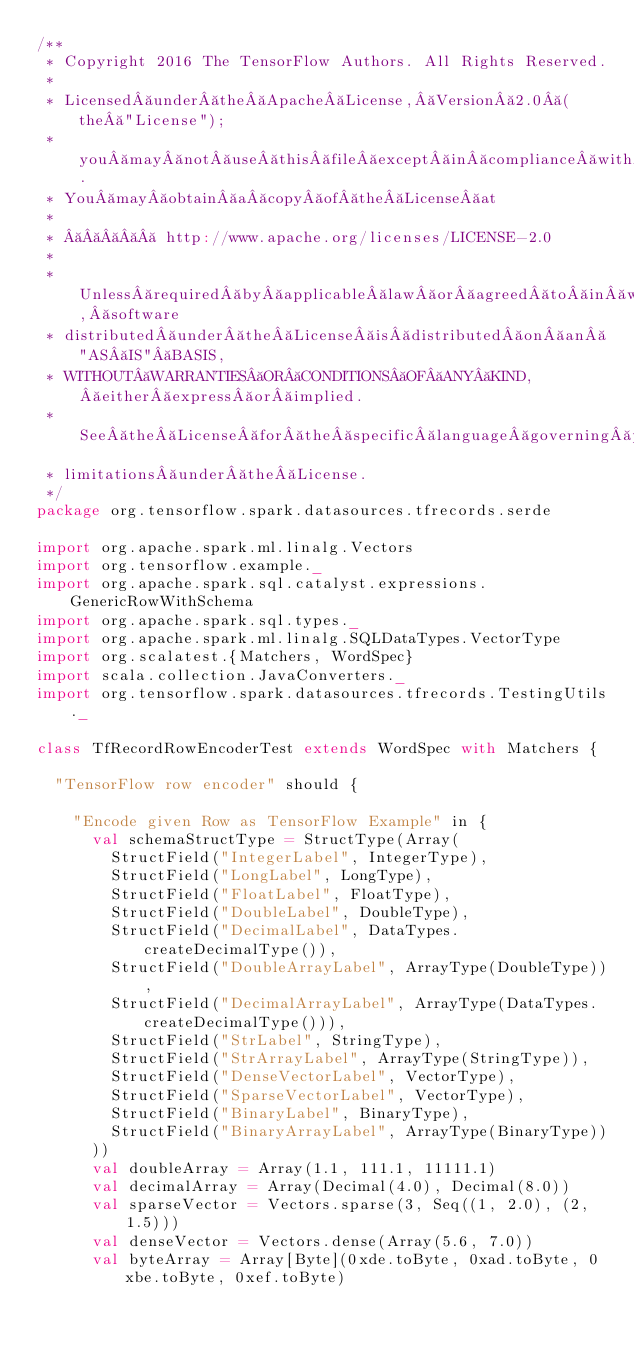<code> <loc_0><loc_0><loc_500><loc_500><_Scala_>/**
 * Copyright 2016 The TensorFlow Authors. All Rights Reserved.
 *
 * Licensed under the Apache License, Version 2.0 (the "License");
 * you may not use this file except in compliance with the License.
 * You may obtain a copy of the License at
 *
 *       http://www.apache.org/licenses/LICENSE-2.0
 *
 * Unless required by applicable law or agreed to in writing, software
 * distributed under the License is distributed on an "AS IS" BASIS,
 * WITHOUT WARRANTIES OR CONDITIONS OF ANY KIND, either express or implied.
 * See the License for the specific language governing permissions and
 * limitations under the License.
 */
package org.tensorflow.spark.datasources.tfrecords.serde

import org.apache.spark.ml.linalg.Vectors
import org.tensorflow.example._
import org.apache.spark.sql.catalyst.expressions.GenericRowWithSchema
import org.apache.spark.sql.types._
import org.apache.spark.ml.linalg.SQLDataTypes.VectorType
import org.scalatest.{Matchers, WordSpec}
import scala.collection.JavaConverters._
import org.tensorflow.spark.datasources.tfrecords.TestingUtils._

class TfRecordRowEncoderTest extends WordSpec with Matchers {

  "TensorFlow row encoder" should {

    "Encode given Row as TensorFlow Example" in {
      val schemaStructType = StructType(Array(
        StructField("IntegerLabel", IntegerType),
        StructField("LongLabel", LongType),
        StructField("FloatLabel", FloatType),
        StructField("DoubleLabel", DoubleType),
        StructField("DecimalLabel", DataTypes.createDecimalType()),
        StructField("DoubleArrayLabel", ArrayType(DoubleType)),
        StructField("DecimalArrayLabel", ArrayType(DataTypes.createDecimalType())),
        StructField("StrLabel", StringType),
        StructField("StrArrayLabel", ArrayType(StringType)),
        StructField("DenseVectorLabel", VectorType),
        StructField("SparseVectorLabel", VectorType),
        StructField("BinaryLabel", BinaryType),
        StructField("BinaryArrayLabel", ArrayType(BinaryType))
      ))
      val doubleArray = Array(1.1, 111.1, 11111.1)
      val decimalArray = Array(Decimal(4.0), Decimal(8.0))
      val sparseVector = Vectors.sparse(3, Seq((1, 2.0), (2, 1.5)))
      val denseVector = Vectors.dense(Array(5.6, 7.0))
      val byteArray = Array[Byte](0xde.toByte, 0xad.toByte, 0xbe.toByte, 0xef.toByte)</code> 